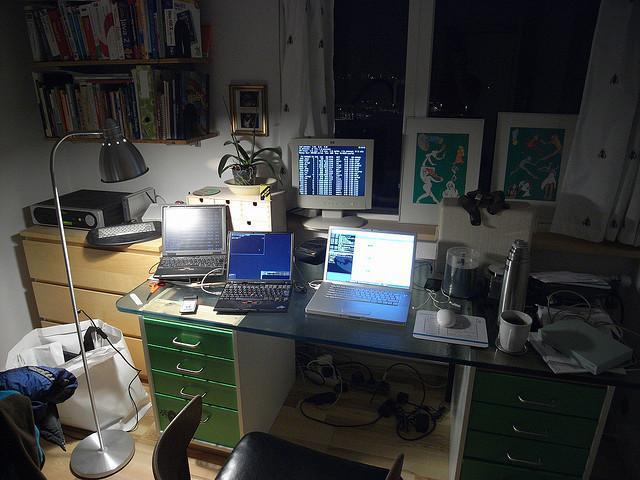How many laptops in the picture?
Give a very brief answer. 3. How many drawers can be seen in the picture?
Give a very brief answer. 11. How many laptops can you see?
Give a very brief answer. 3. 